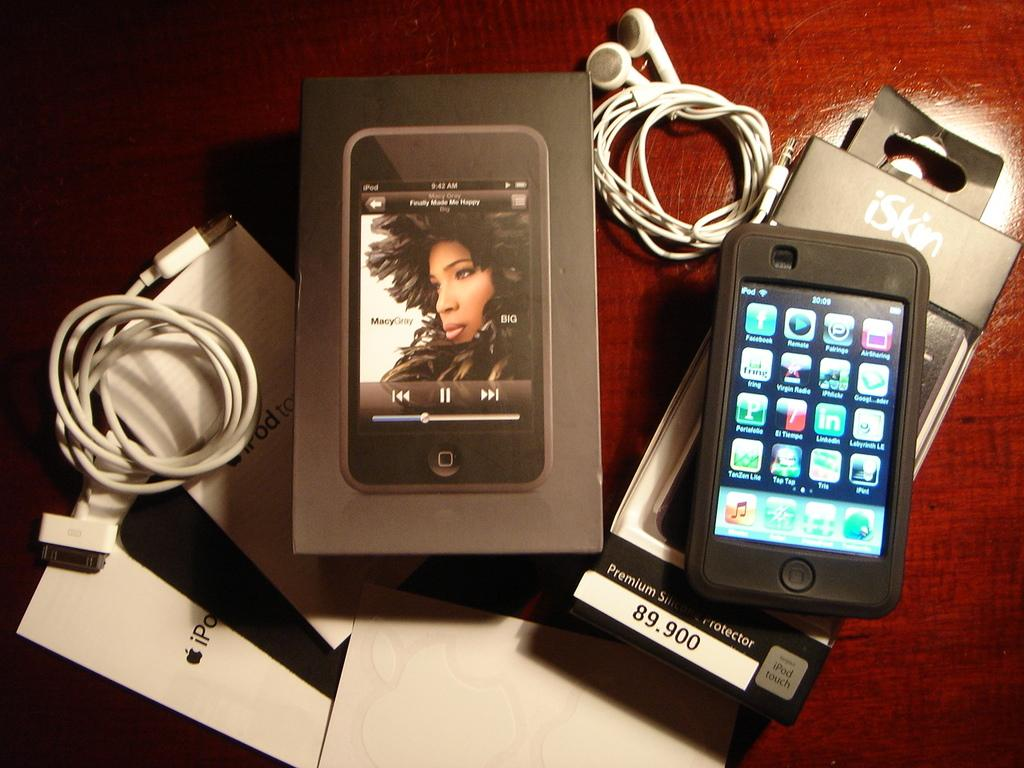What electronic device is visible in the image? There is a cell phone in the image. What accessory is present for the cell phone? There is a headset in the image. What connects the headset to the cell phone? There is a wire in the image. What type of items can be seen on the table in the image? Papers and a box are visible on the table in the image. What type of sock is being used to taste the cell phone in the image? There is no sock or tasting involved in the image; it features a cell phone, headset, wire, papers, and a box on a table. 